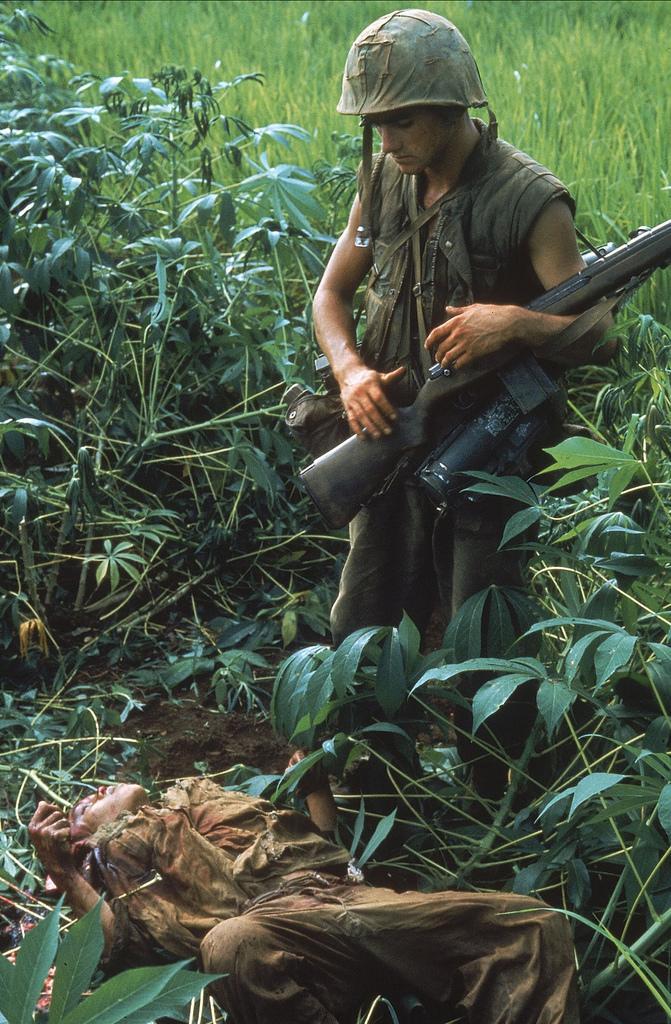How would you summarize this image in a sentence or two? In the middle of this image, there is a person wearing a helmet, holding a gun and standing. Beside him, there is a person lying on the ground and there are plants which are having green color leaves. In the background, there is a farm field. 